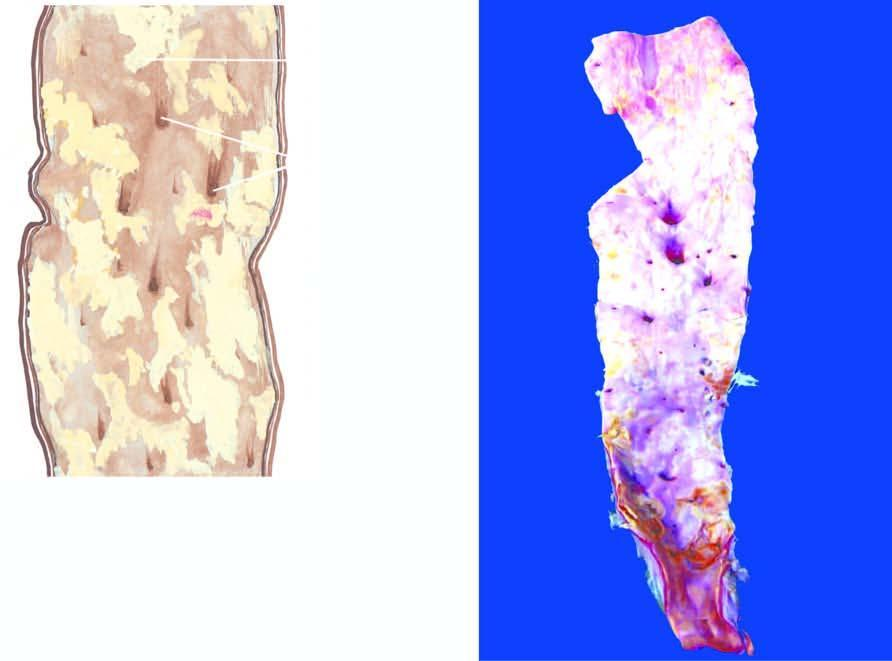re some raised yellowish-white lesions raised above the surface?
Answer the question using a single word or phrase. Yes 